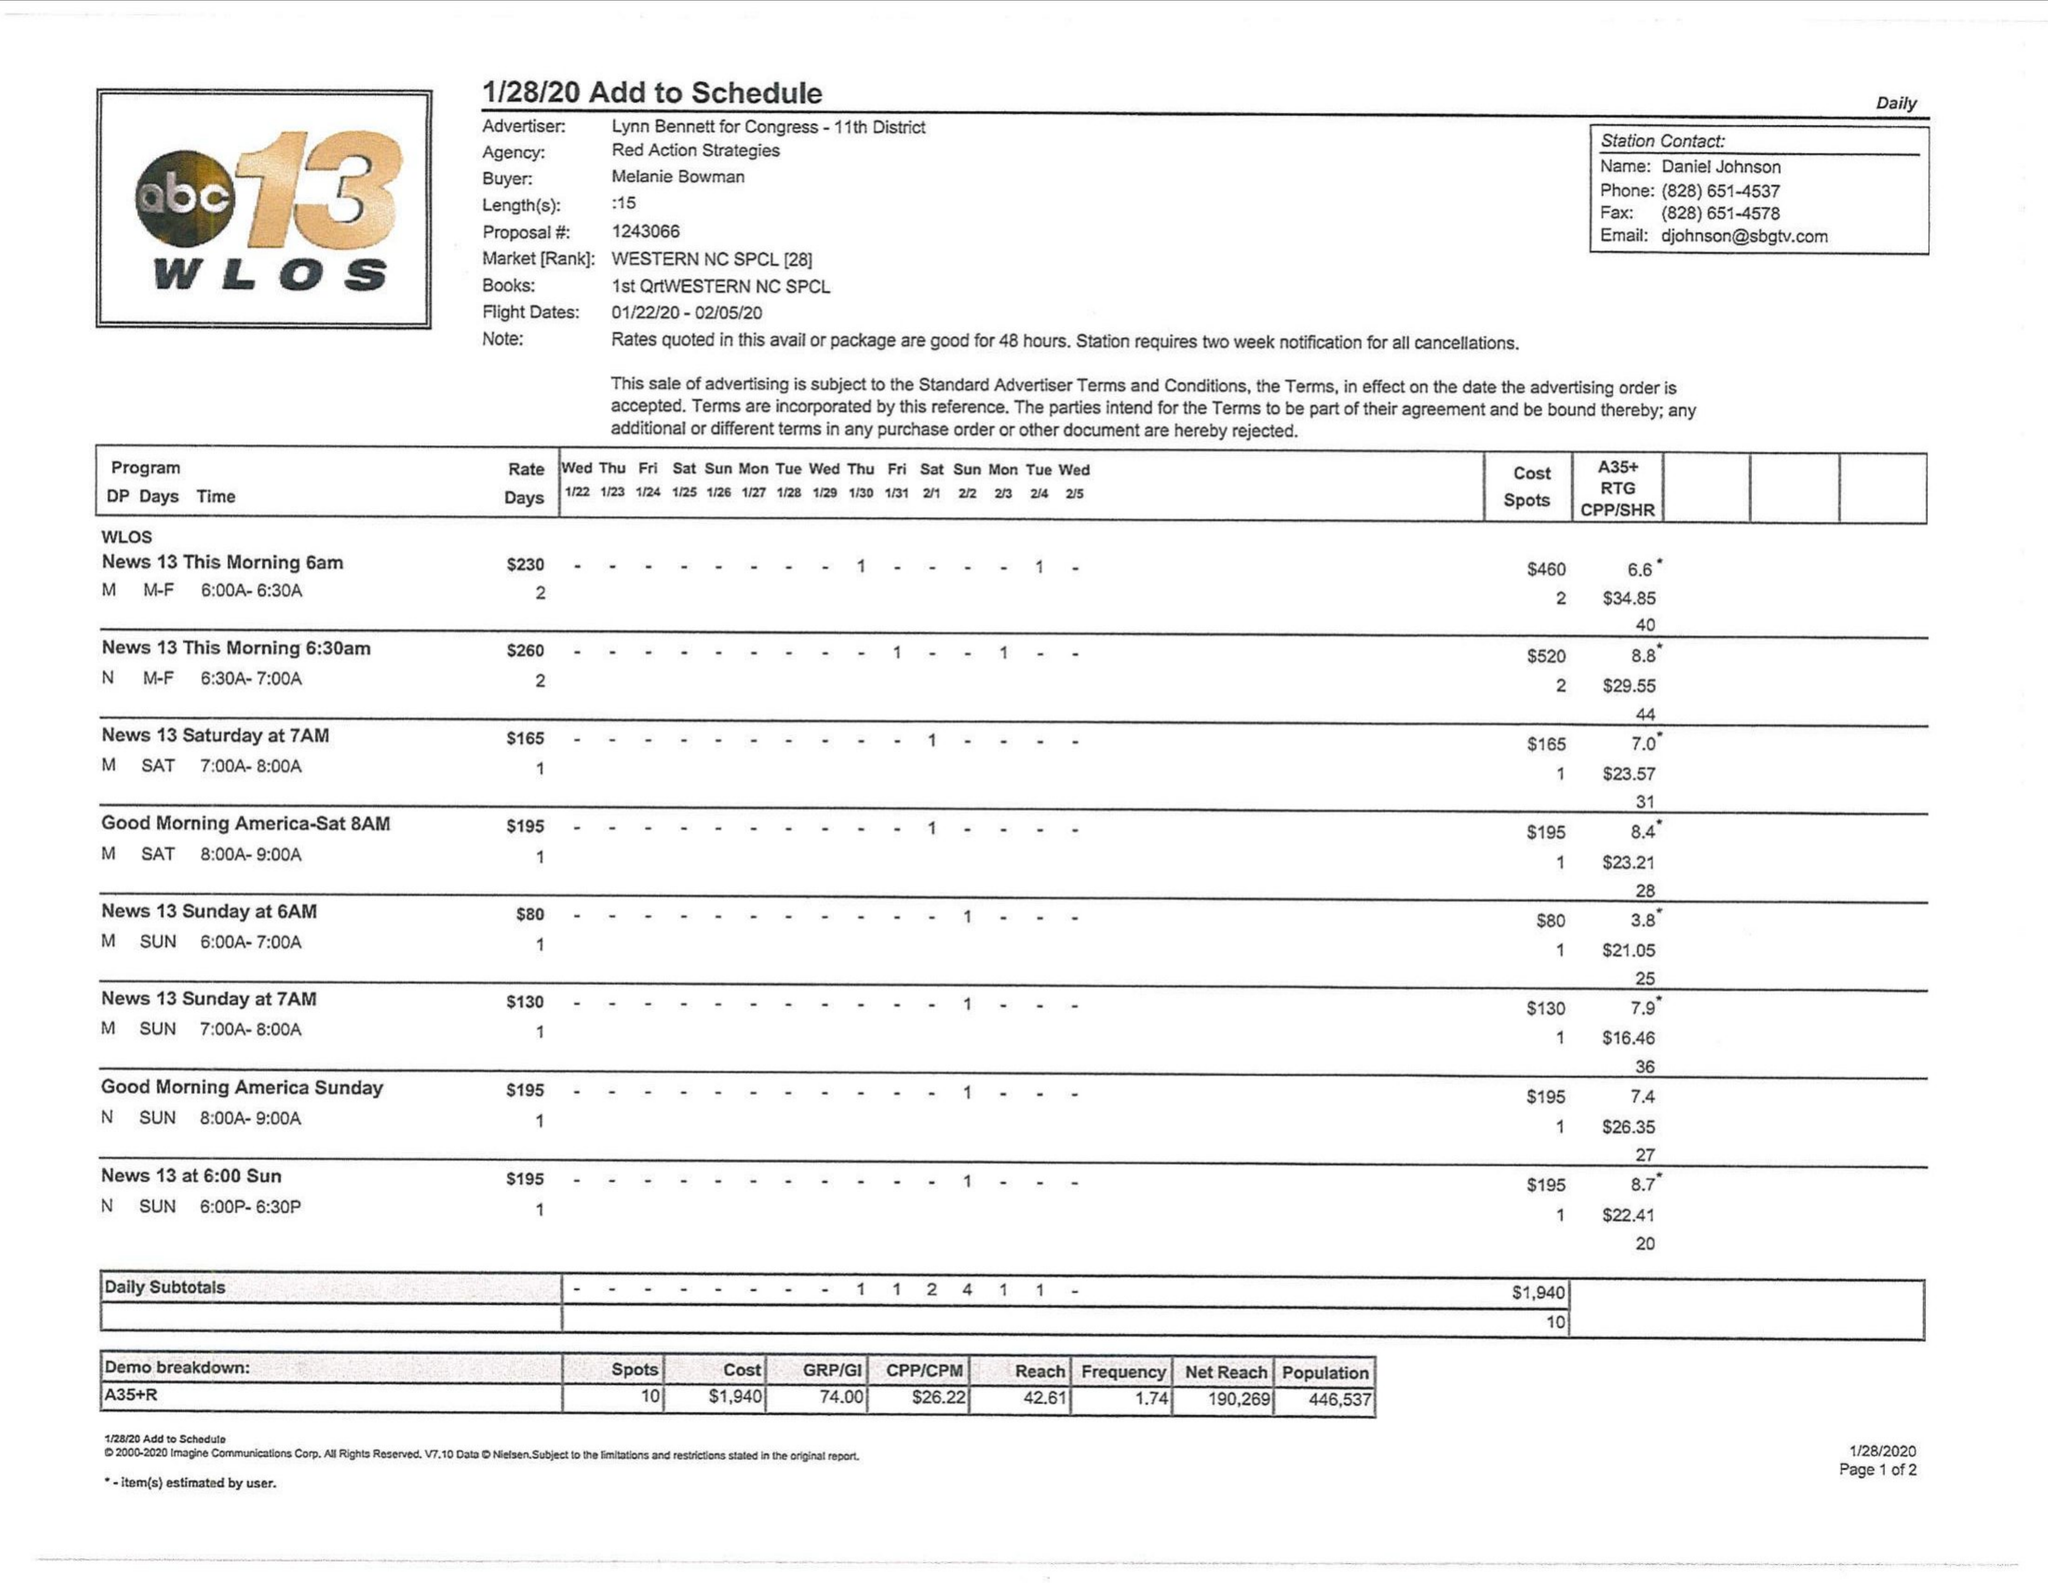What is the value for the flight_from?
Answer the question using a single word or phrase. 01/22/20 